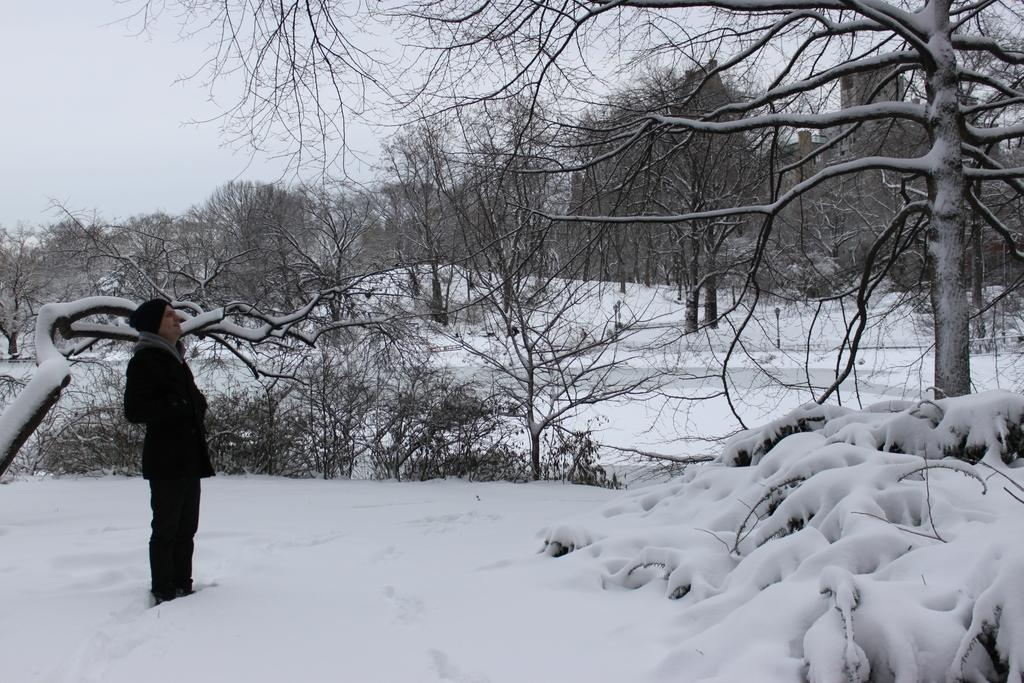What is present in the image? There is a person in the image. Can you describe the person's attire? The person is wearing a cap. What is the condition of the land in the image? The land in the image is covered with snow. What can be seen in the background of the image? There are plants and trees in the background of the image. What is visible at the top of the image? The sky is visible at the top of the image. How many pizzas are being served on the ground in the image? There are no pizzas present in the image, and the ground is covered with snow. What type of orange is visible in the image? There is no orange present in the image. 